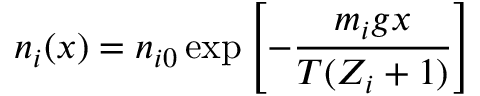Convert formula to latex. <formula><loc_0><loc_0><loc_500><loc_500>n _ { i } ( x ) = n _ { i 0 } \exp \left [ - { \frac { m _ { i } g x } { T ( Z _ { i } + 1 ) } } \right ]</formula> 